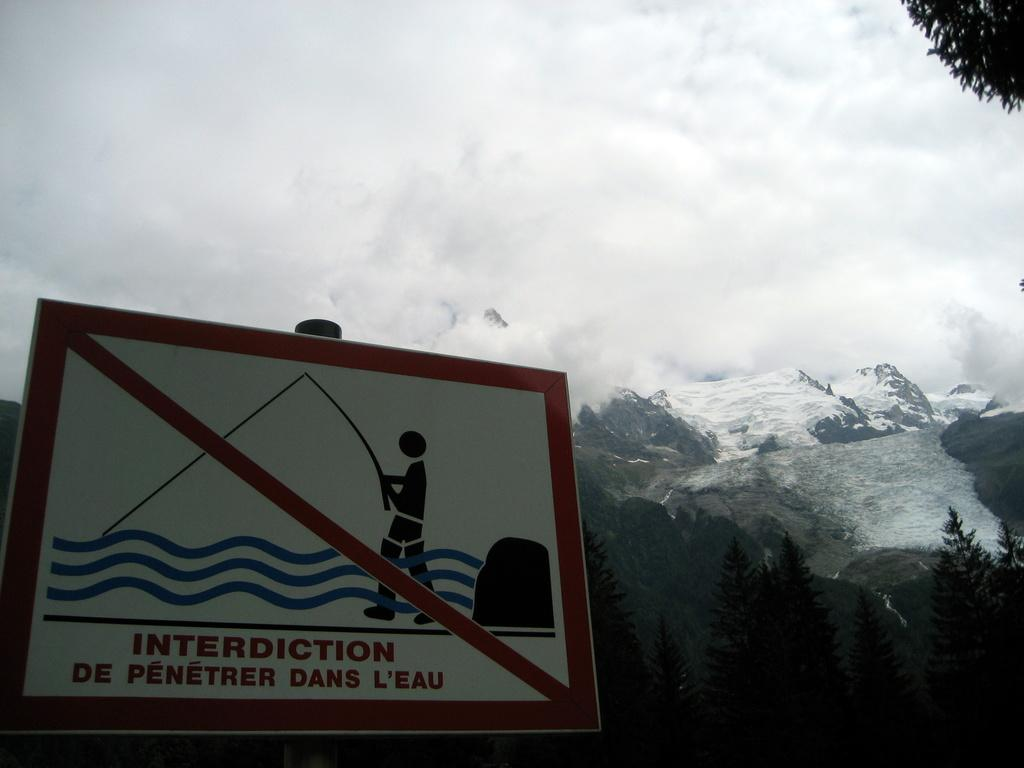<image>
Give a short and clear explanation of the subsequent image. A sign that says interdiction in front of a mountain. 